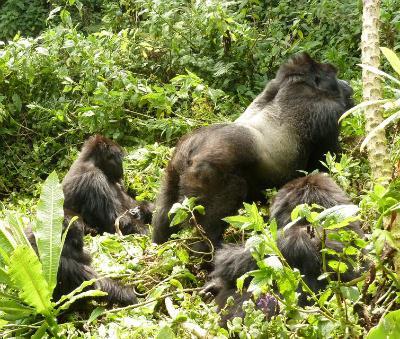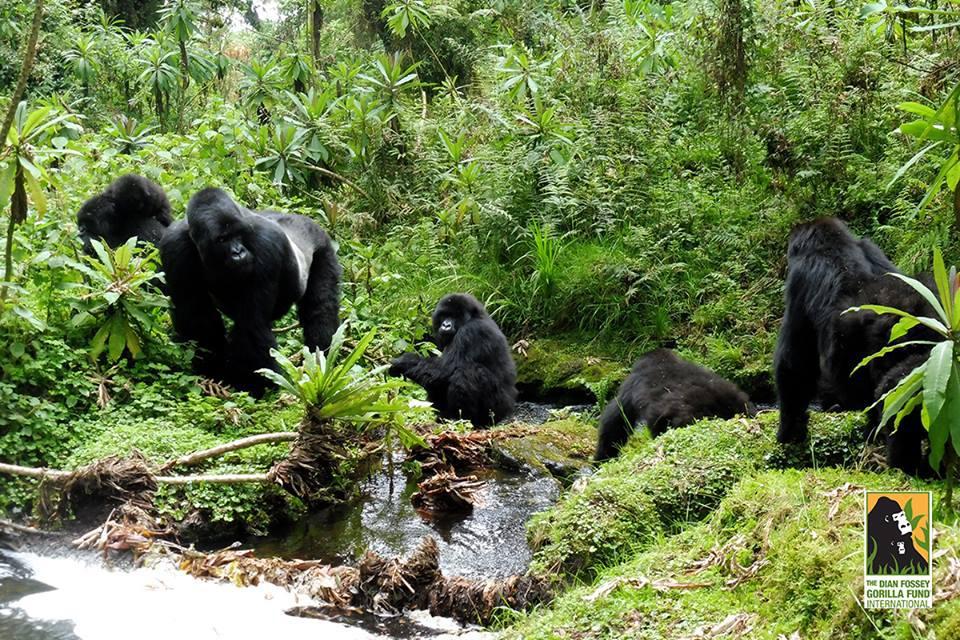The first image is the image on the left, the second image is the image on the right. For the images displayed, is the sentence "The left image includes a rear-facing adult gorilla on all fours, with its body turned rightward and smaller gorillas around it." factually correct? Answer yes or no. Yes. The first image is the image on the left, the second image is the image on the right. For the images shown, is this caption "The right image contains no more than one gorilla." true? Answer yes or no. No. 